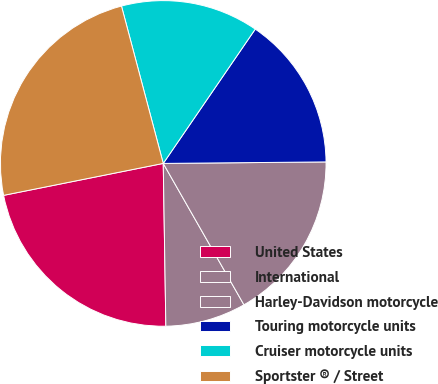Convert chart. <chart><loc_0><loc_0><loc_500><loc_500><pie_chart><fcel>United States<fcel>International<fcel>Harley-Davidson motorcycle<fcel>Touring motorcycle units<fcel>Cruiser motorcycle units<fcel>Sportster ® / Street<nl><fcel>22.11%<fcel>8.0%<fcel>16.89%<fcel>15.29%<fcel>13.69%<fcel>24.01%<nl></chart> 